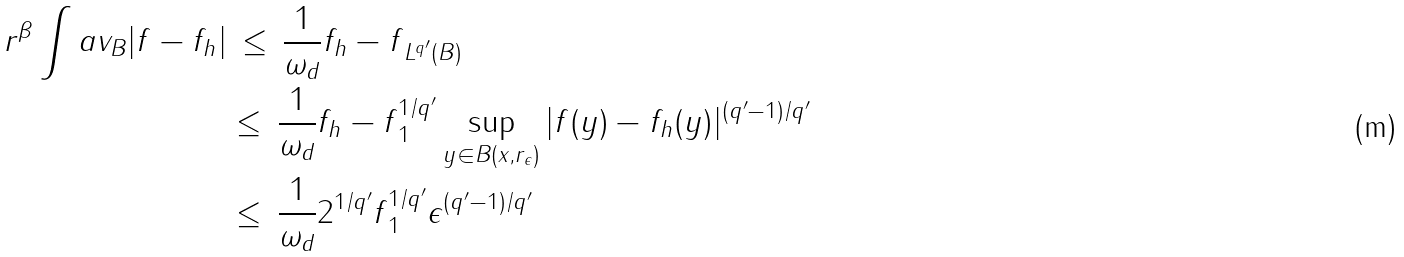<formula> <loc_0><loc_0><loc_500><loc_500>r ^ { \beta } \int a v _ { B } | f - f _ { h } | & \, \leq \, \frac { 1 } { \omega _ { d } } \| f _ { h } - f \| _ { L ^ { q ^ { \prime } } ( B ) } \\ & \leq \, \frac { 1 } { \omega _ { d } } \| f _ { h } - f \| ^ { 1 / q ^ { \prime } } _ { 1 } \sup _ { y \in B ( x , r _ { \epsilon } ) } | f ( y ) - f _ { h } ( y ) | ^ { ( q ^ { \prime } - 1 ) / q ^ { \prime } } \\ & \leq \, \frac { 1 } { \omega _ { d } } 2 ^ { 1 / q ^ { \prime } } \| f \| ^ { 1 / q ^ { \prime } } _ { 1 } \epsilon ^ { ( q ^ { \prime } - 1 ) / q ^ { \prime } }</formula> 